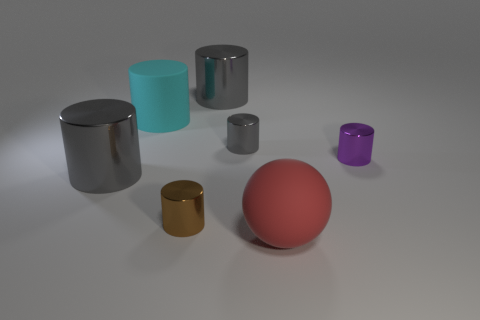There is a tiny object that is both in front of the tiny gray object and left of the purple metallic object; what shape is it?
Your answer should be compact. Cylinder. There is a purple metallic cylinder to the right of the small brown shiny cylinder; does it have the same size as the rubber object on the left side of the large rubber sphere?
Provide a short and direct response. No. How many gray cylinders have the same material as the tiny brown cylinder?
Make the answer very short. 3. Do the purple metallic thing and the small gray thing have the same shape?
Your response must be concise. Yes. There is a gray object that is to the left of the large gray metallic cylinder that is behind the gray thing in front of the small purple cylinder; what is its size?
Keep it short and to the point. Large. There is a large metallic thing that is behind the small gray metallic thing; are there any metallic cylinders that are to the left of it?
Your answer should be compact. Yes. There is a large gray cylinder right of the big matte object that is behind the small gray cylinder; how many metal cylinders are on the left side of it?
Your response must be concise. 2. What is the color of the large thing that is both behind the purple metallic cylinder and left of the small brown cylinder?
Offer a terse response. Cyan. What is the color of the rubber sphere that is the same size as the cyan rubber cylinder?
Offer a very short reply. Red. There is a small metal thing in front of the small object that is right of the red sphere; is there a sphere on the left side of it?
Your response must be concise. No. 